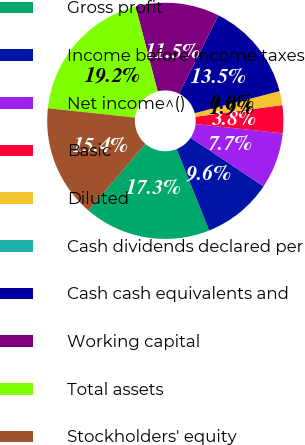Convert chart to OTSL. <chart><loc_0><loc_0><loc_500><loc_500><pie_chart><fcel>Gross profit<fcel>Income before income taxes<fcel>Net income^()<fcel>Basic<fcel>Diluted<fcel>Cash dividends declared per<fcel>Cash cash equivalents and<fcel>Working capital<fcel>Total assets<fcel>Stockholders' equity<nl><fcel>17.34%<fcel>9.58%<fcel>7.66%<fcel>3.83%<fcel>1.92%<fcel>0.0%<fcel>13.51%<fcel>11.49%<fcel>19.25%<fcel>15.42%<nl></chart> 